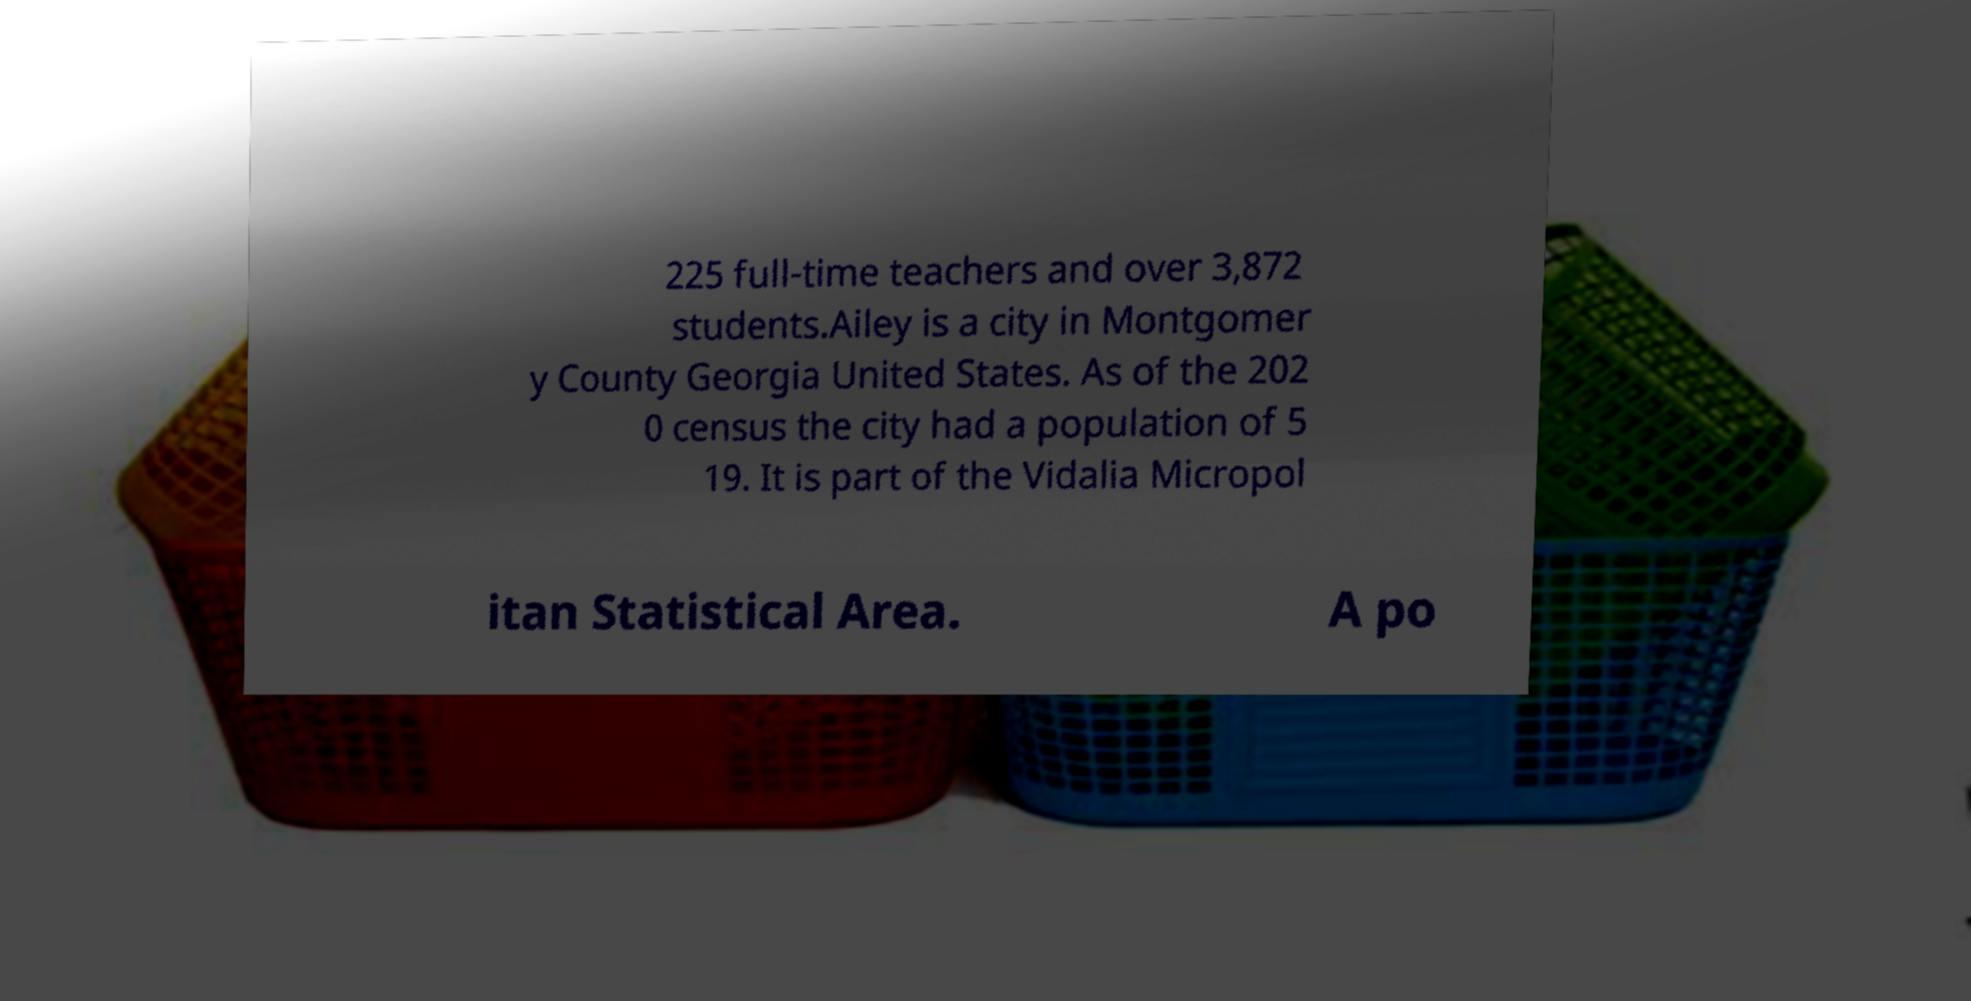Please read and relay the text visible in this image. What does it say? 225 full-time teachers and over 3,872 students.Ailey is a city in Montgomer y County Georgia United States. As of the 202 0 census the city had a population of 5 19. It is part of the Vidalia Micropol itan Statistical Area. A po 